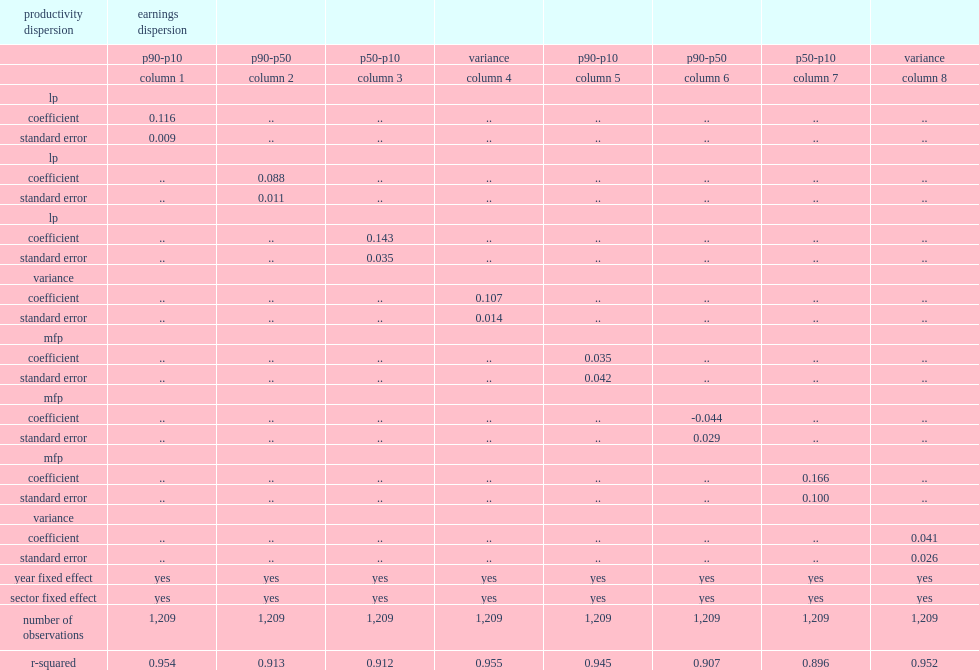What was the percentage of increase in the earnings dispersion of the estimated coefficient suggests that an increase of 1% in the dispersion of lp? 0.116. What was the correlation coefficient, which is only slightly smaller than the earnings dispersion measure? 0.107. Would you mind parsing the complete table? {'header': ['productivity dispersion', 'earnings dispersion', '', '', '', '', '', '', ''], 'rows': [['', 'p90-p10', 'p90-p50', 'p50-p10', 'variance', 'p90-p10', 'p90-p50', 'p50-p10', 'variance'], ['', 'column 1', 'column 2', 'column 3', 'column 4', 'column 5', 'column 6', 'column 7', 'column 8'], ['lp', '', '', '', '', '', '', '', ''], ['coefficient', '0.116', '..', '..', '..', '..', '..', '..', '..'], ['standard error', '0.009', '..', '..', '..', '..', '..', '..', '..'], ['lp', '', '', '', '', '', '', '', ''], ['coefficient', '..', '0.088', '..', '..', '..', '..', '..', '..'], ['standard error', '..', '0.011', '..', '..', '..', '..', '..', '..'], ['lp', '', '', '', '', '', '', '', ''], ['coefficient', '..', '..', '0.143', '..', '..', '..', '..', '..'], ['standard error', '..', '..', '0.035', '..', '..', '..', '..', '..'], ['variance', '', '', '', '', '', '', '', ''], ['coefficient', '..', '..', '..', '0.107', '..', '..', '..', '..'], ['standard error', '..', '..', '..', '0.014', '..', '..', '..', '..'], ['mfp', '', '', '', '', '', '', '', ''], ['coefficient', '..', '..', '..', '..', '0.035', '..', '..', '..'], ['standard error', '..', '..', '..', '..', '0.042', '..', '..', '..'], ['mfp', '', '', '', '', '', '', '', ''], ['coefficient', '..', '..', '..', '..', '..', '-0.044', '..', '..'], ['standard error', '..', '..', '..', '..', '..', '0.029', '..', '..'], ['mfp', '', '', '', '', '', '', '', ''], ['coefficient', '..', '..', '..', '..', '..', '..', '0.166', '..'], ['standard error', '..', '..', '..', '..', '..', '..', '0.100', '..'], ['variance', '', '', '', '', '', '', '', ''], ['coefficient', '..', '..', '..', '..', '..', '..', '..', '0.041'], ['standard error', '..', '..', '..', '..', '..', '..', '..', '0.026'], ['year fixed effect', 'yes', 'yes', 'yes', 'yes', 'yes', 'yes', 'yes', 'yes'], ['sector fixed effect', 'yes', 'yes', 'yes', 'yes', 'yes', 'yes', 'yes', 'yes'], ['number of observations', '1,209', '1,209', '1,209', '1,209', '1,209', '1,209', '1,209', '1,209'], ['r-squared', '0.954', '0.913', '0.912', '0.955', '0.945', '0.907', '0.896', '0.952']]} 